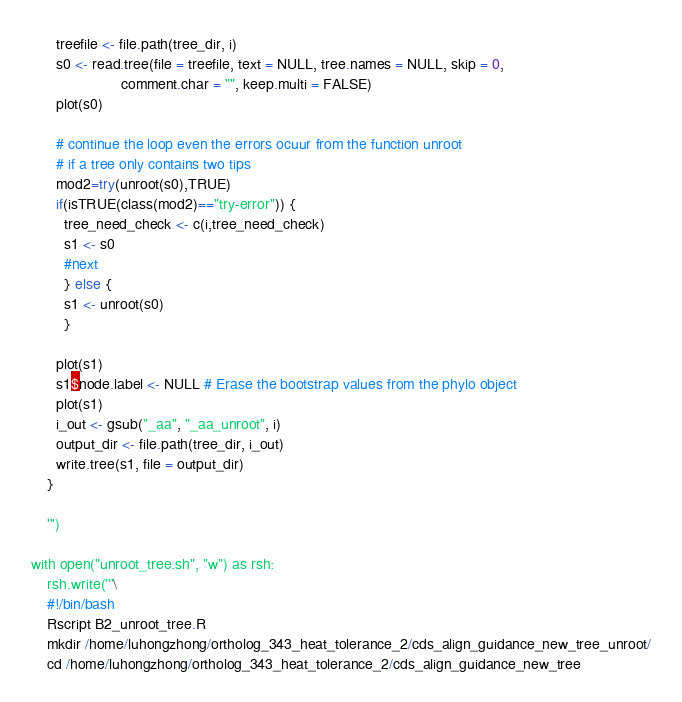<code> <loc_0><loc_0><loc_500><loc_500><_Python_>      treefile <- file.path(tree_dir, i)
      s0 <- read.tree(file = treefile, text = NULL, tree.names = NULL, skip = 0,
                      comment.char = "", keep.multi = FALSE)
      plot(s0)

      # continue the loop even the errors ocuur from the function unroot  
      # if a tree only contains two tips
      mod2=try(unroot(s0),TRUE)
      if(isTRUE(class(mod2)=="try-error")) { 
        tree_need_check <- c(i,tree_need_check)
        s1 <- s0
        #next 
        } else { 
        s1 <- unroot(s0)
        } 

      plot(s1)
      s1$node.label <- NULL # Erase the bootstrap values from the phylo object
      plot(s1)
      i_out <- gsub("_aa", "_aa_unroot", i)
      output_dir <- file.path(tree_dir, i_out)
      write.tree(s1, file = output_dir)
    }

    ''')

with open("unroot_tree.sh", "w") as rsh:
    rsh.write('''\
    #!/bin/bash
    Rscript B2_unroot_tree.R
    mkdir /home/luhongzhong/ortholog_343_heat_tolerance_2/cds_align_guidance_new_tree_unroot/
    cd /home/luhongzhong/ortholog_343_heat_tolerance_2/cds_align_guidance_new_tree</code> 